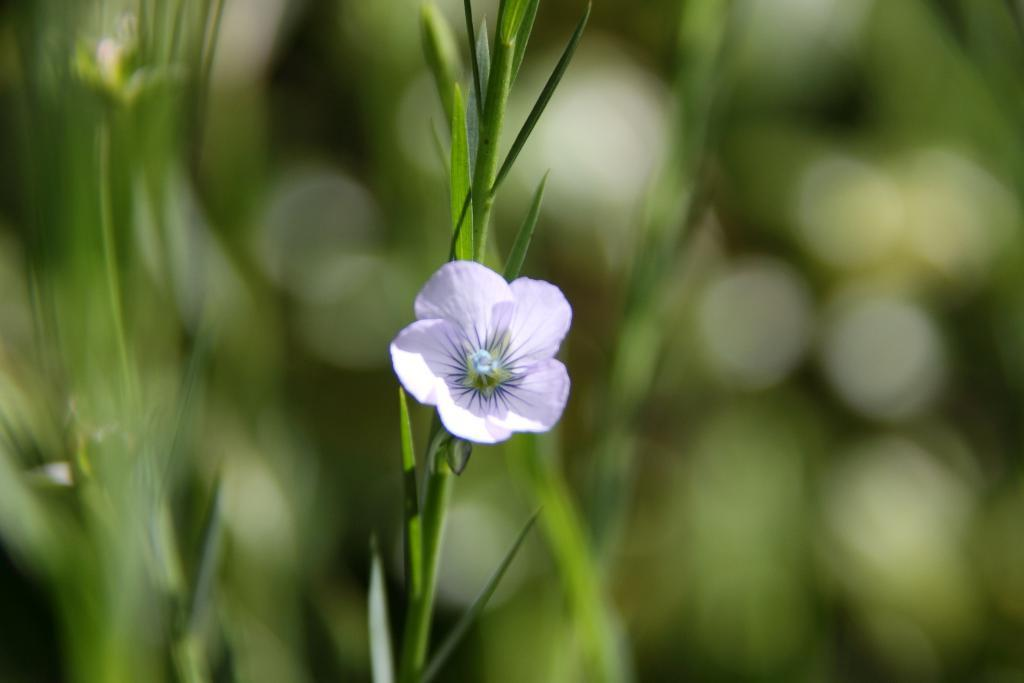What is the main subject of the image? There is a flower on a plant in the image. Can you describe the surrounding environment in the image? There are other plants visible in the background of the image. How would you describe the quality of the image? The image is blurry. How many dimes are scattered around the flower in the image? There are no dimes present in the image; it features a flower on a plant and other plants in the background. 